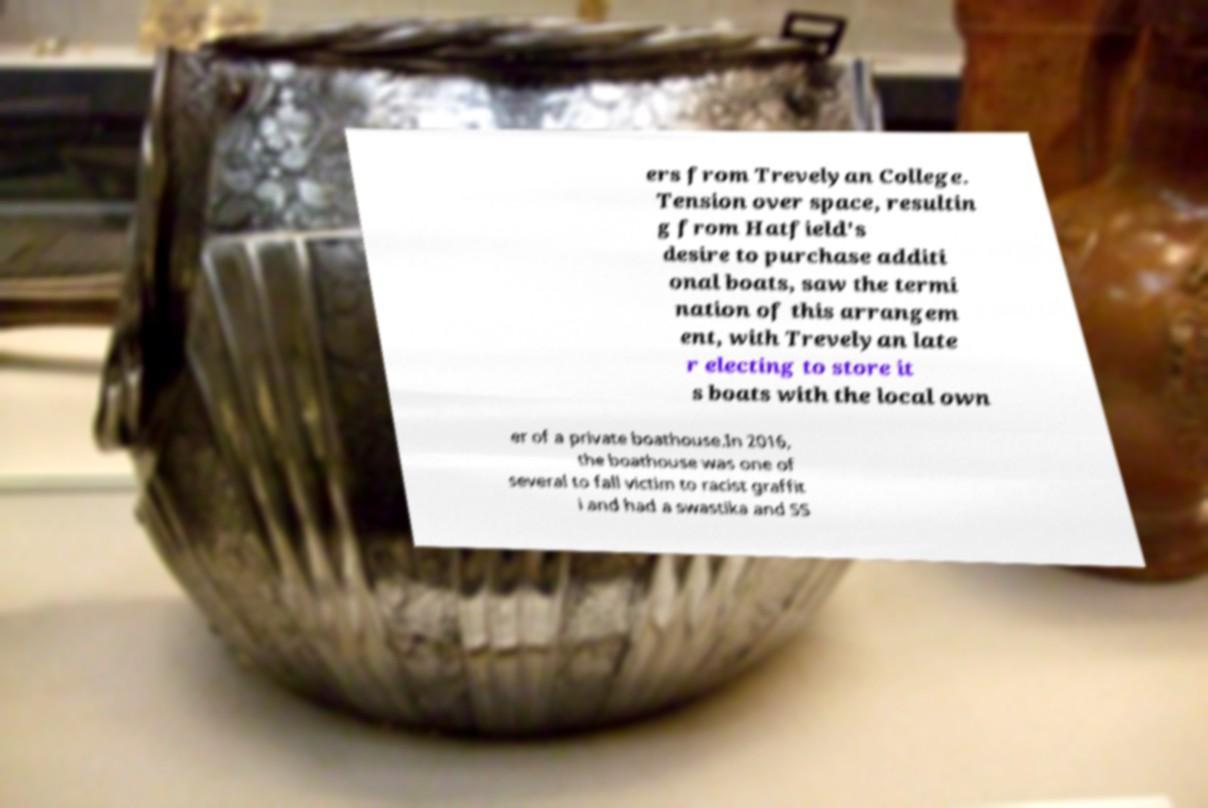Please identify and transcribe the text found in this image. ers from Trevelyan College. Tension over space, resultin g from Hatfield's desire to purchase additi onal boats, saw the termi nation of this arrangem ent, with Trevelyan late r electing to store it s boats with the local own er of a private boathouse.In 2016, the boathouse was one of several to fall victim to racist graffit i and had a swastika and SS 